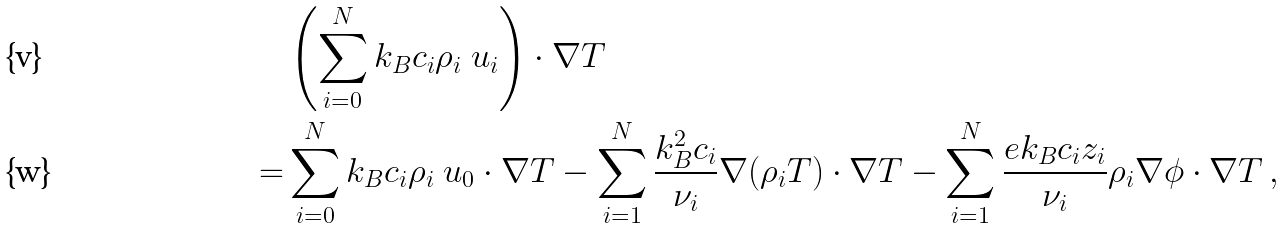Convert formula to latex. <formula><loc_0><loc_0><loc_500><loc_500>& \left ( \sum _ { i = 0 } ^ { N } k _ { B } c _ { i } \rho _ { i } \ u _ { i } \right ) \cdot \nabla T \\ = & \sum _ { i = 0 } ^ { N } k _ { B } c _ { i } \rho _ { i } \ u _ { 0 } \cdot \nabla T - \sum _ { i = 1 } ^ { N } \frac { k _ { B } ^ { 2 } c _ { i } } { \nu _ { i } } \nabla ( \rho _ { i } T ) \cdot \nabla T - \sum _ { i = 1 } ^ { N } \frac { e k _ { B } c _ { i } z _ { i } } { \nu _ { i } } \rho _ { i } \nabla \phi \cdot \nabla T \, ,</formula> 